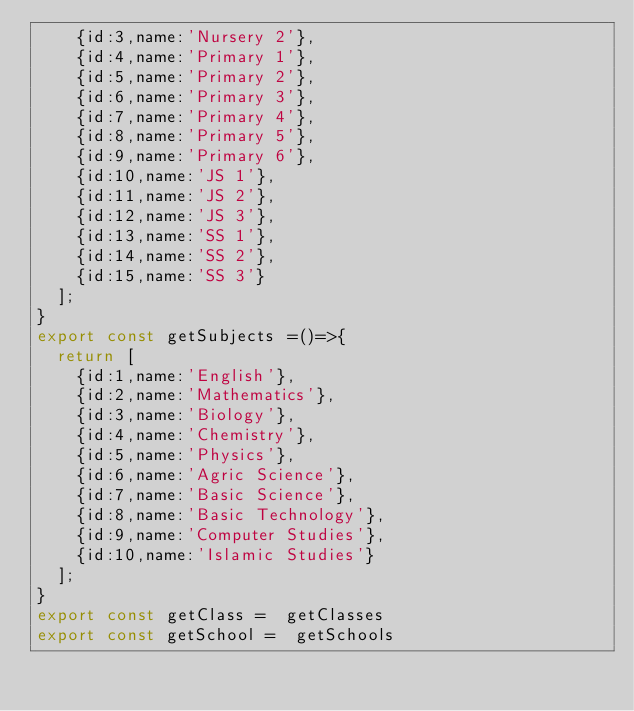<code> <loc_0><loc_0><loc_500><loc_500><_JavaScript_>		{id:3,name:'Nursery 2'},
		{id:4,name:'Primary 1'},
		{id:5,name:'Primary 2'},
		{id:6,name:'Primary 3'},
		{id:7,name:'Primary 4'},
		{id:8,name:'Primary 5'},
		{id:9,name:'Primary 6'},
		{id:10,name:'JS 1'},
		{id:11,name:'JS 2'},
		{id:12,name:'JS 3'},
		{id:13,name:'SS 1'},
		{id:14,name:'SS 2'},
		{id:15,name:'SS 3'}
	];
}
export const getSubjects =()=>{
	return [
		{id:1,name:'English'},
		{id:2,name:'Mathematics'},
		{id:3,name:'Biology'},
		{id:4,name:'Chemistry'},
		{id:5,name:'Physics'},
		{id:6,name:'Agric Science'},
		{id:7,name:'Basic Science'},
		{id:8,name:'Basic Technology'},
		{id:9,name:'Computer Studies'},
		{id:10,name:'Islamic Studies'}
	];
}
export const getClass =  getClasses
export const getSchool =  getSchools</code> 